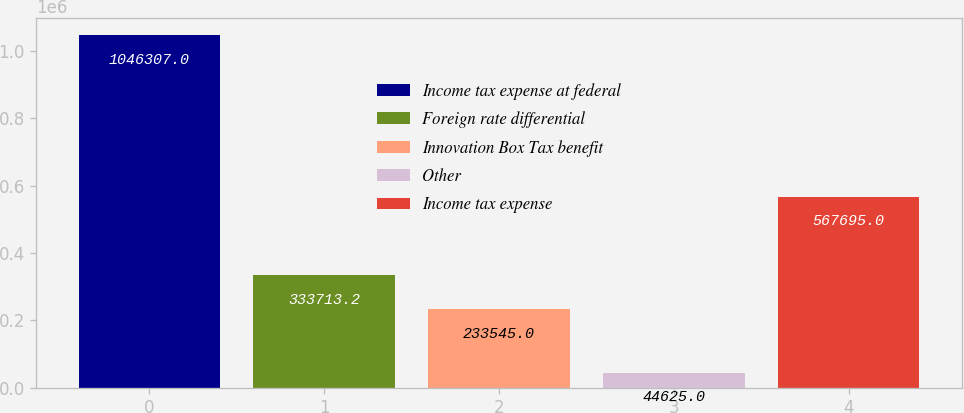Convert chart. <chart><loc_0><loc_0><loc_500><loc_500><bar_chart><fcel>Income tax expense at federal<fcel>Foreign rate differential<fcel>Innovation Box Tax benefit<fcel>Other<fcel>Income tax expense<nl><fcel>1.04631e+06<fcel>333713<fcel>233545<fcel>44625<fcel>567695<nl></chart> 